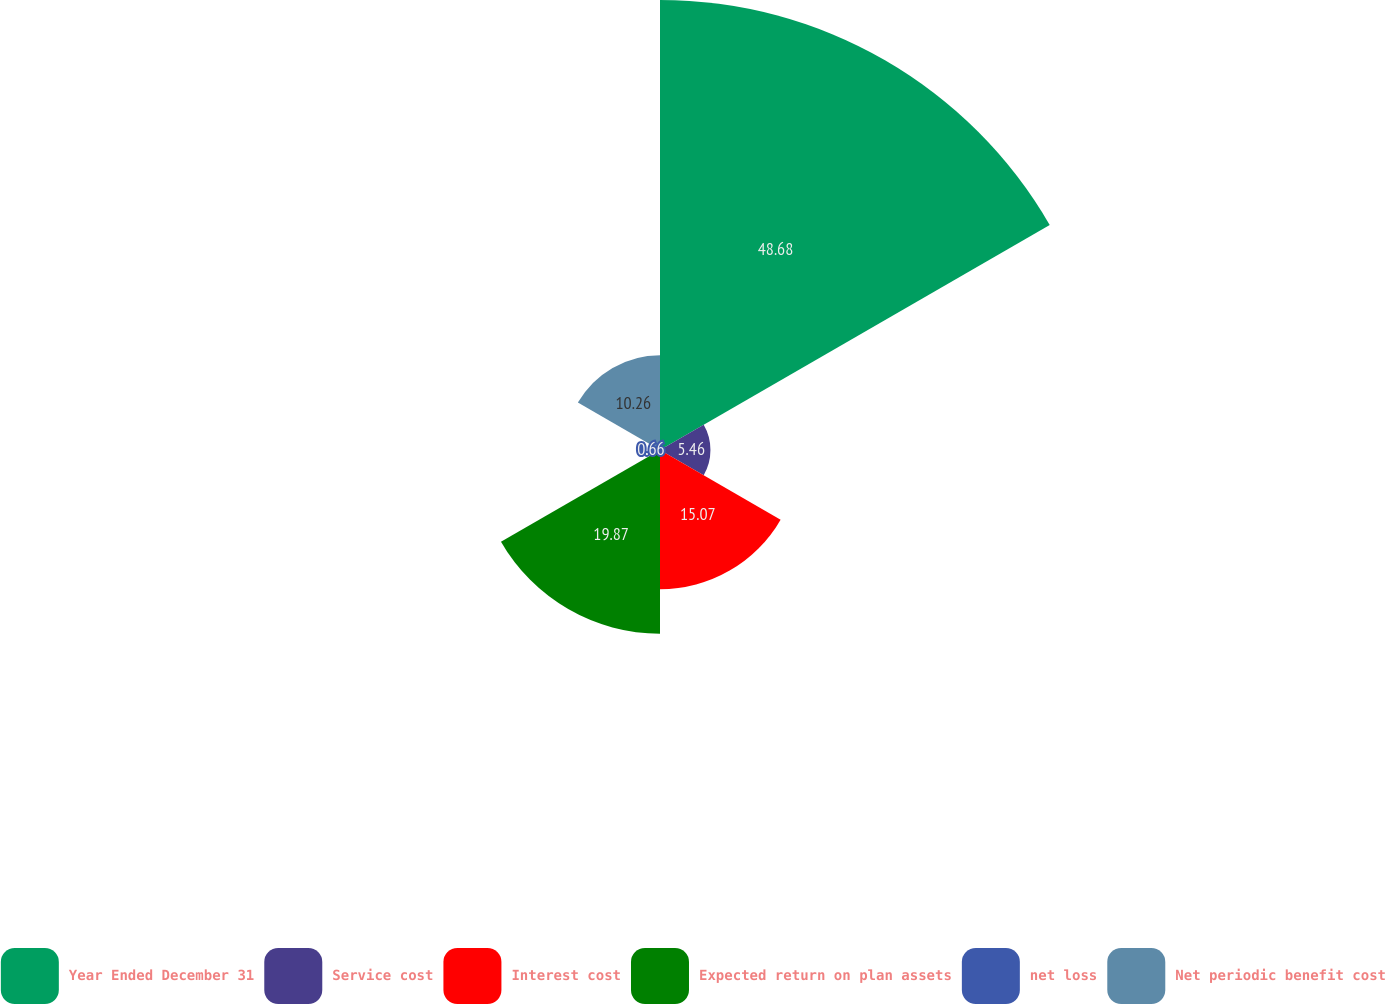Convert chart. <chart><loc_0><loc_0><loc_500><loc_500><pie_chart><fcel>Year Ended December 31<fcel>Service cost<fcel>Interest cost<fcel>Expected return on plan assets<fcel>net loss<fcel>Net periodic benefit cost<nl><fcel>48.69%<fcel>5.46%<fcel>15.07%<fcel>19.87%<fcel>0.66%<fcel>10.26%<nl></chart> 